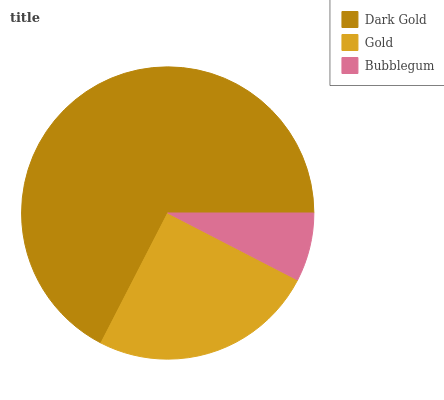Is Bubblegum the minimum?
Answer yes or no. Yes. Is Dark Gold the maximum?
Answer yes or no. Yes. Is Gold the minimum?
Answer yes or no. No. Is Gold the maximum?
Answer yes or no. No. Is Dark Gold greater than Gold?
Answer yes or no. Yes. Is Gold less than Dark Gold?
Answer yes or no. Yes. Is Gold greater than Dark Gold?
Answer yes or no. No. Is Dark Gold less than Gold?
Answer yes or no. No. Is Gold the high median?
Answer yes or no. Yes. Is Gold the low median?
Answer yes or no. Yes. Is Dark Gold the high median?
Answer yes or no. No. Is Dark Gold the low median?
Answer yes or no. No. 